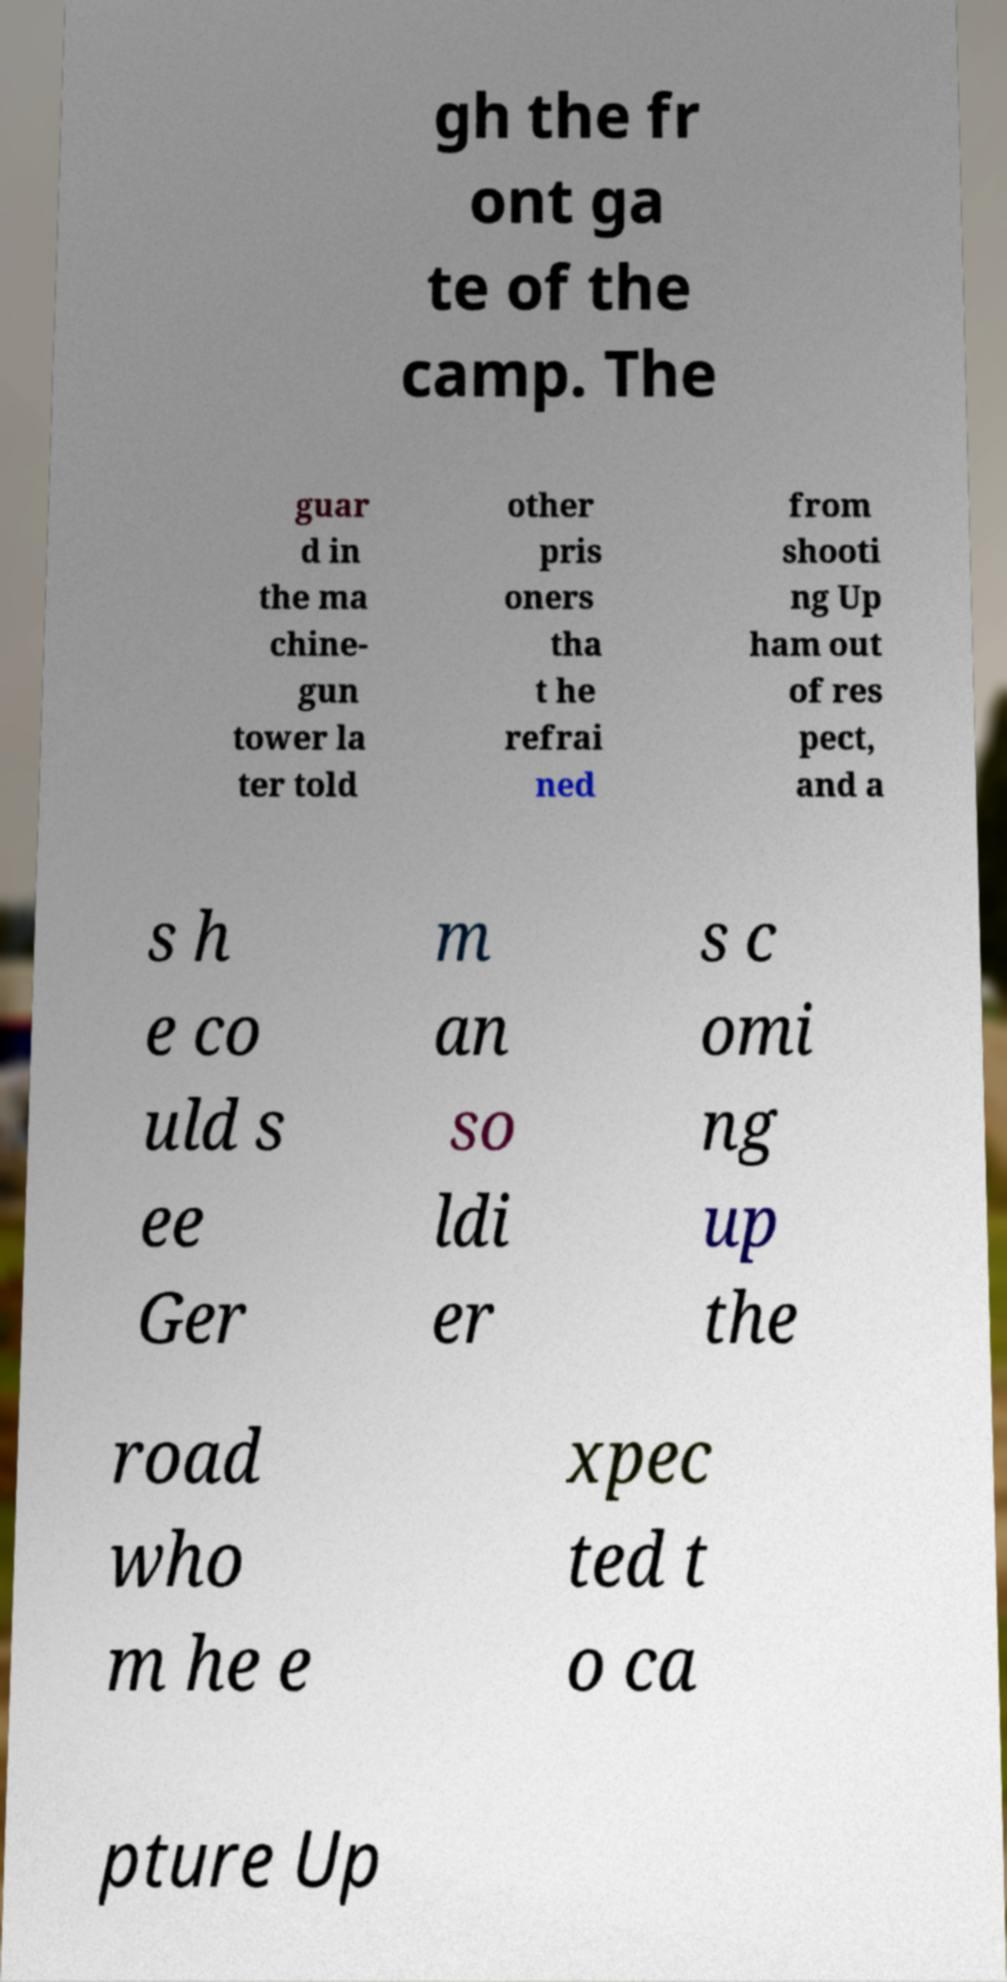What messages or text are displayed in this image? I need them in a readable, typed format. gh the fr ont ga te of the camp. The guar d in the ma chine- gun tower la ter told other pris oners tha t he refrai ned from shooti ng Up ham out of res pect, and a s h e co uld s ee Ger m an so ldi er s c omi ng up the road who m he e xpec ted t o ca pture Up 